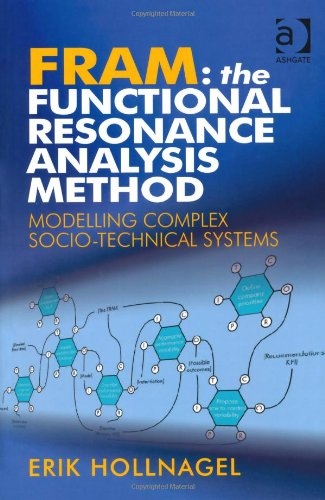Is this book related to Computers & Technology? Yes, the book is deeply rooted in the Computers & Technology genre, providing insights into systems theory and its application in real-world socio-technical environments. 